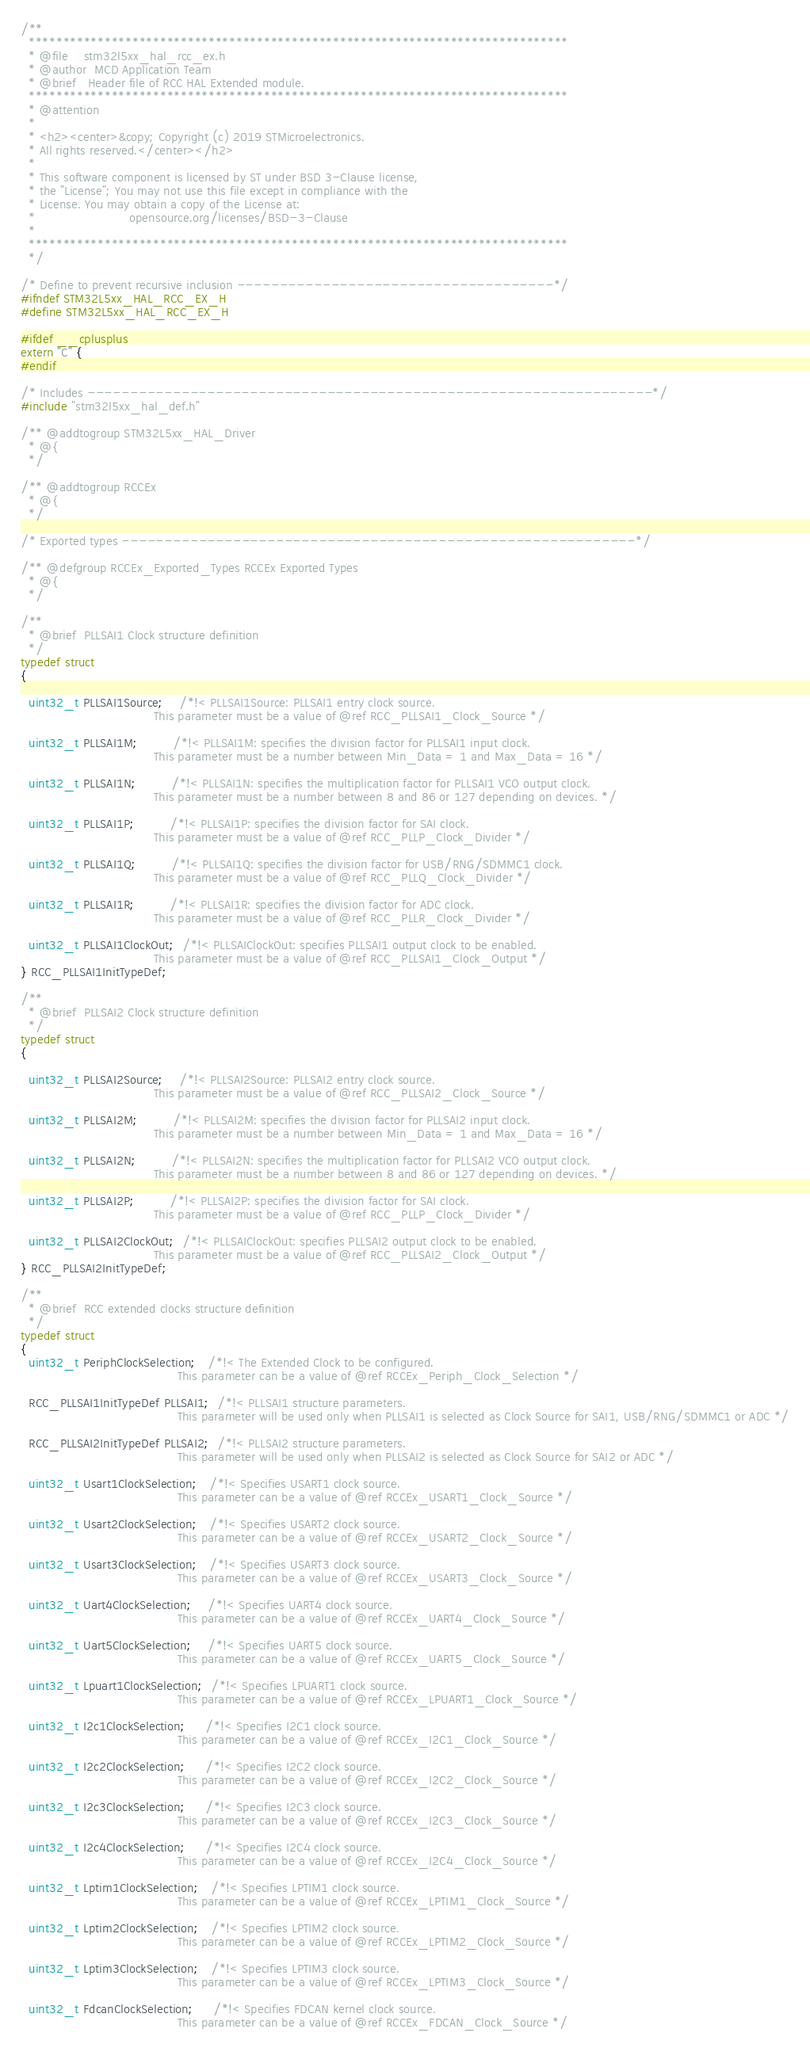<code> <loc_0><loc_0><loc_500><loc_500><_C_>/**
  ******************************************************************************
  * @file    stm32l5xx_hal_rcc_ex.h
  * @author  MCD Application Team
  * @brief   Header file of RCC HAL Extended module.
  ******************************************************************************
  * @attention
  *
  * <h2><center>&copy; Copyright (c) 2019 STMicroelectronics.
  * All rights reserved.</center></h2>
  *
  * This software component is licensed by ST under BSD 3-Clause license,
  * the "License"; You may not use this file except in compliance with the
  * License. You may obtain a copy of the License at:
  *                        opensource.org/licenses/BSD-3-Clause
  *
  ******************************************************************************
  */

/* Define to prevent recursive inclusion -------------------------------------*/
#ifndef STM32L5xx_HAL_RCC_EX_H
#define STM32L5xx_HAL_RCC_EX_H

#ifdef __cplusplus
extern "C" {
#endif

/* Includes ------------------------------------------------------------------*/
#include "stm32l5xx_hal_def.h"

/** @addtogroup STM32L5xx_HAL_Driver
  * @{
  */

/** @addtogroup RCCEx
  * @{
  */

/* Exported types ------------------------------------------------------------*/

/** @defgroup RCCEx_Exported_Types RCCEx Exported Types
  * @{
  */

/**
  * @brief  PLLSAI1 Clock structure definition
  */
typedef struct
{

  uint32_t PLLSAI1Source;    /*!< PLLSAI1Source: PLLSAI1 entry clock source.
                                  This parameter must be a value of @ref RCC_PLLSAI1_Clock_Source */

  uint32_t PLLSAI1M;         /*!< PLLSAI1M: specifies the division factor for PLLSAI1 input clock.
                                  This parameter must be a number between Min_Data = 1 and Max_Data = 16 */

  uint32_t PLLSAI1N;         /*!< PLLSAI1N: specifies the multiplication factor for PLLSAI1 VCO output clock.
                                  This parameter must be a number between 8 and 86 or 127 depending on devices. */

  uint32_t PLLSAI1P;         /*!< PLLSAI1P: specifies the division factor for SAI clock.
                                  This parameter must be a value of @ref RCC_PLLP_Clock_Divider */

  uint32_t PLLSAI1Q;         /*!< PLLSAI1Q: specifies the division factor for USB/RNG/SDMMC1 clock.
                                  This parameter must be a value of @ref RCC_PLLQ_Clock_Divider */

  uint32_t PLLSAI1R;         /*!< PLLSAI1R: specifies the division factor for ADC clock.
                                  This parameter must be a value of @ref RCC_PLLR_Clock_Divider */

  uint32_t PLLSAI1ClockOut;  /*!< PLLSAIClockOut: specifies PLLSAI1 output clock to be enabled.
                                  This parameter must be a value of @ref RCC_PLLSAI1_Clock_Output */
} RCC_PLLSAI1InitTypeDef;

/**
  * @brief  PLLSAI2 Clock structure definition
  */
typedef struct
{

  uint32_t PLLSAI2Source;    /*!< PLLSAI2Source: PLLSAI2 entry clock source.
                                  This parameter must be a value of @ref RCC_PLLSAI2_Clock_Source */

  uint32_t PLLSAI2M;         /*!< PLLSAI2M: specifies the division factor for PLLSAI2 input clock.
                                  This parameter must be a number between Min_Data = 1 and Max_Data = 16 */

  uint32_t PLLSAI2N;         /*!< PLLSAI2N: specifies the multiplication factor for PLLSAI2 VCO output clock.
                                  This parameter must be a number between 8 and 86 or 127 depending on devices. */

  uint32_t PLLSAI2P;         /*!< PLLSAI2P: specifies the division factor for SAI clock.
                                  This parameter must be a value of @ref RCC_PLLP_Clock_Divider */

  uint32_t PLLSAI2ClockOut;  /*!< PLLSAIClockOut: specifies PLLSAI2 output clock to be enabled.
                                  This parameter must be a value of @ref RCC_PLLSAI2_Clock_Output */
} RCC_PLLSAI2InitTypeDef;

/**
  * @brief  RCC extended clocks structure definition
  */
typedef struct
{
  uint32_t PeriphClockSelection;   /*!< The Extended Clock to be configured.
                                        This parameter can be a value of @ref RCCEx_Periph_Clock_Selection */

  RCC_PLLSAI1InitTypeDef PLLSAI1;  /*!< PLLSAI1 structure parameters.
                                        This parameter will be used only when PLLSAI1 is selected as Clock Source for SAI1, USB/RNG/SDMMC1 or ADC */

  RCC_PLLSAI2InitTypeDef PLLSAI2;  /*!< PLLSAI2 structure parameters.
                                        This parameter will be used only when PLLSAI2 is selected as Clock Source for SAI2 or ADC */

  uint32_t Usart1ClockSelection;   /*!< Specifies USART1 clock source.
                                        This parameter can be a value of @ref RCCEx_USART1_Clock_Source */

  uint32_t Usart2ClockSelection;   /*!< Specifies USART2 clock source.
                                        This parameter can be a value of @ref RCCEx_USART2_Clock_Source */

  uint32_t Usart3ClockSelection;   /*!< Specifies USART3 clock source.
                                        This parameter can be a value of @ref RCCEx_USART3_Clock_Source */

  uint32_t Uart4ClockSelection;    /*!< Specifies UART4 clock source.
                                        This parameter can be a value of @ref RCCEx_UART4_Clock_Source */

  uint32_t Uart5ClockSelection;    /*!< Specifies UART5 clock source.
                                        This parameter can be a value of @ref RCCEx_UART5_Clock_Source */

  uint32_t Lpuart1ClockSelection;  /*!< Specifies LPUART1 clock source.
                                        This parameter can be a value of @ref RCCEx_LPUART1_Clock_Source */

  uint32_t I2c1ClockSelection;     /*!< Specifies I2C1 clock source.
                                        This parameter can be a value of @ref RCCEx_I2C1_Clock_Source */

  uint32_t I2c2ClockSelection;     /*!< Specifies I2C2 clock source.
                                        This parameter can be a value of @ref RCCEx_I2C2_Clock_Source */

  uint32_t I2c3ClockSelection;     /*!< Specifies I2C3 clock source.
                                        This parameter can be a value of @ref RCCEx_I2C3_Clock_Source */

  uint32_t I2c4ClockSelection;     /*!< Specifies I2C4 clock source.
                                        This parameter can be a value of @ref RCCEx_I2C4_Clock_Source */

  uint32_t Lptim1ClockSelection;   /*!< Specifies LPTIM1 clock source.
                                        This parameter can be a value of @ref RCCEx_LPTIM1_Clock_Source */

  uint32_t Lptim2ClockSelection;   /*!< Specifies LPTIM2 clock source.
                                        This parameter can be a value of @ref RCCEx_LPTIM2_Clock_Source */

  uint32_t Lptim3ClockSelection;   /*!< Specifies LPTIM3 clock source.
                                        This parameter can be a value of @ref RCCEx_LPTIM3_Clock_Source */

  uint32_t FdcanClockSelection;     /*!< Specifies FDCAN kernel clock source.
                                        This parameter can be a value of @ref RCCEx_FDCAN_Clock_Source */
</code> 